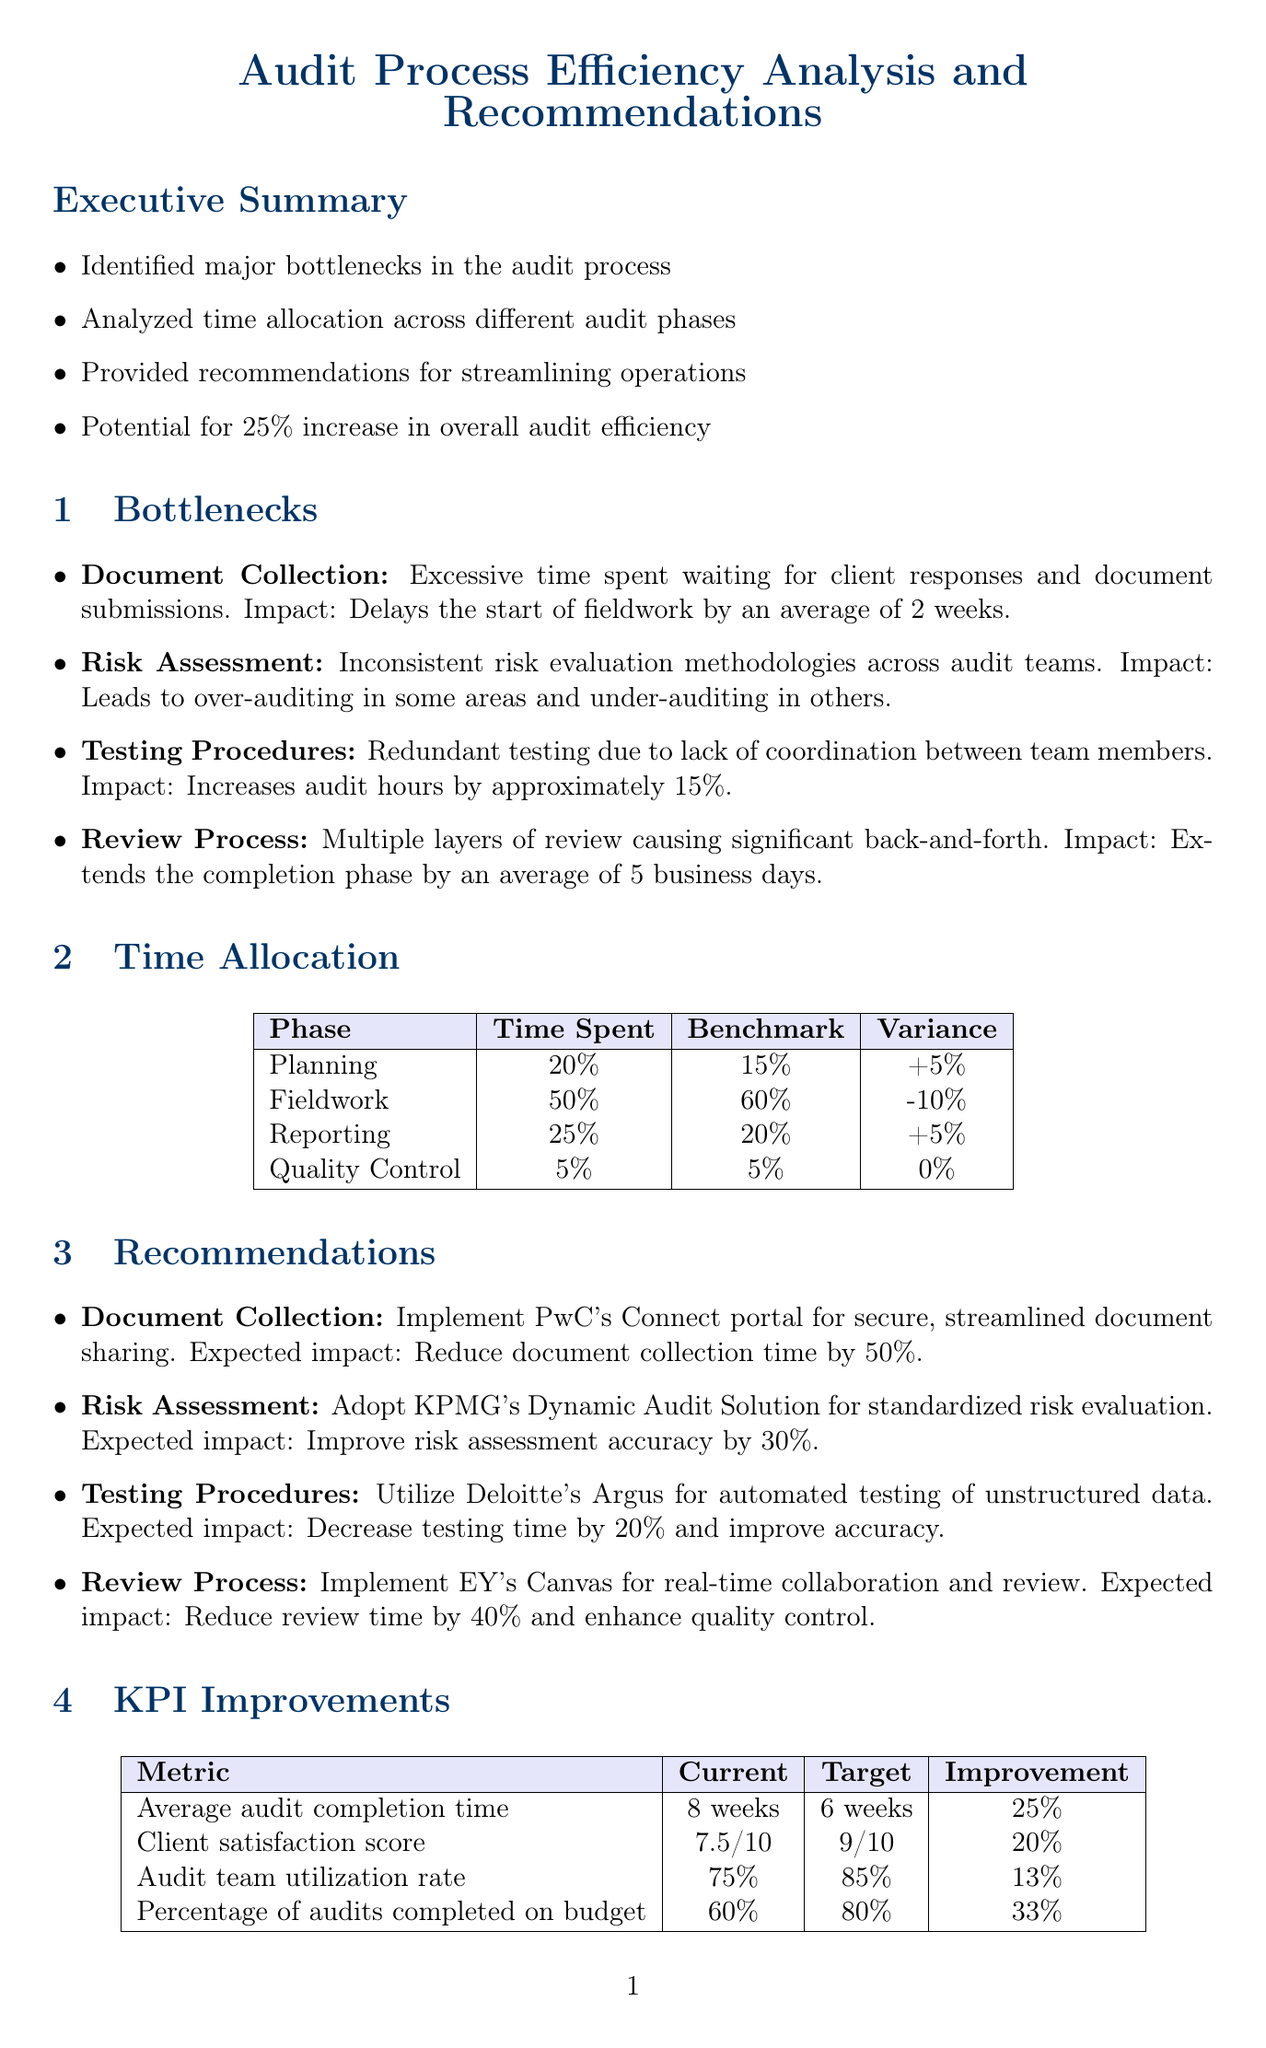What is the title of the report? The title of the report is mentioned at the beginning of the document.
Answer: Audit Process Efficiency Analysis and Recommendations What is the average delay caused by the document collection bottleneck? The document describes the impact of the bottleneck on the timeline.
Answer: 2 weeks What is the time spent in the Fieldwork phase? The document provides specific time allocation for each phase.
Answer: 50% What is the expected impact of implementing PwC's Connect portal? The document states the expected outcome of a recommended action.
Answer: Reduce document collection time by 50% What is the target for the average audit completion time? The report outlines metrics for improvement with current and target values.
Answer: 6 weeks What recommendation is made for the Review Process? The document specifies recommendations for different bottlenecks.
Answer: Implement EY's Canvas for real-time collaboration and review How much can client satisfaction increase? The document includes metrics detailing possible improvements for client satisfaction.
Answer: 20% What is the total duration for the Technology Integration phase? The report lists the duration needed for each implementation phase.
Answer: 3 months What is the KPI improvement for the percentage of audits completed on budget? The document specifies the current and target metrics along with improvements.
Answer: 33% 